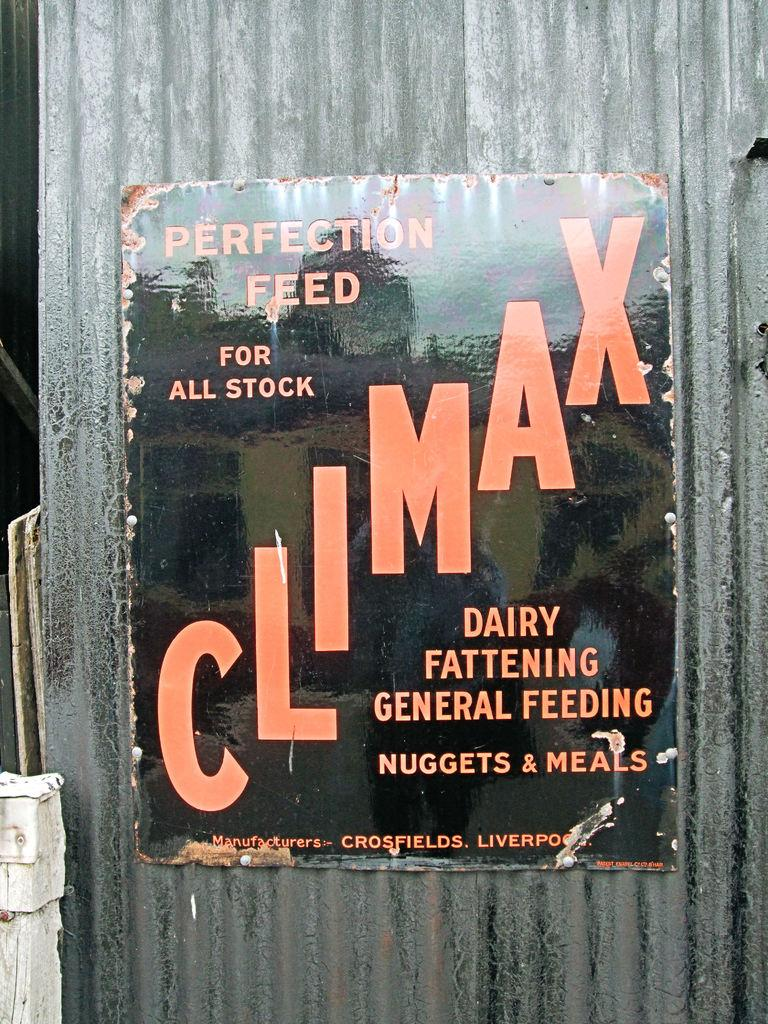Provide a one-sentence caption for the provided image. A sign on a building that reads Climax and says Perfection feed for all stock. 